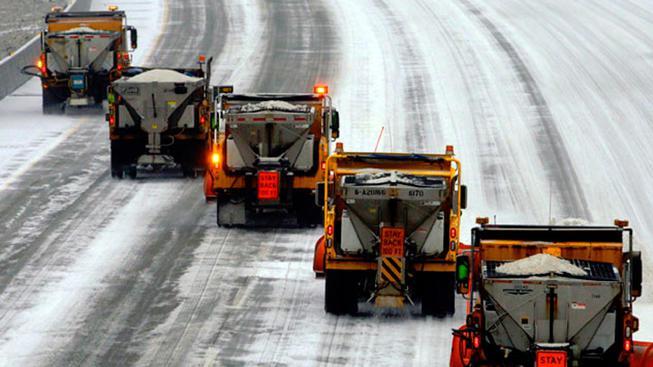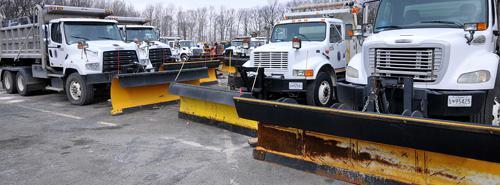The first image is the image on the left, the second image is the image on the right. For the images displayed, is the sentence "One of the images shows two plows and the other shows only one plow." factually correct? Answer yes or no. No. The first image is the image on the left, the second image is the image on the right. Evaluate the accuracy of this statement regarding the images: "The left and right image contains a total of three trucks.". Is it true? Answer yes or no. No. 